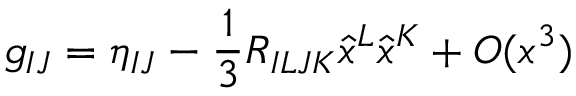Convert formula to latex. <formula><loc_0><loc_0><loc_500><loc_500>g _ { I J } = \eta _ { I J } - \frac { 1 } { 3 } R _ { I L J K } \hat { x } ^ { L } \hat { x } ^ { K } + O ( x ^ { 3 } )</formula> 